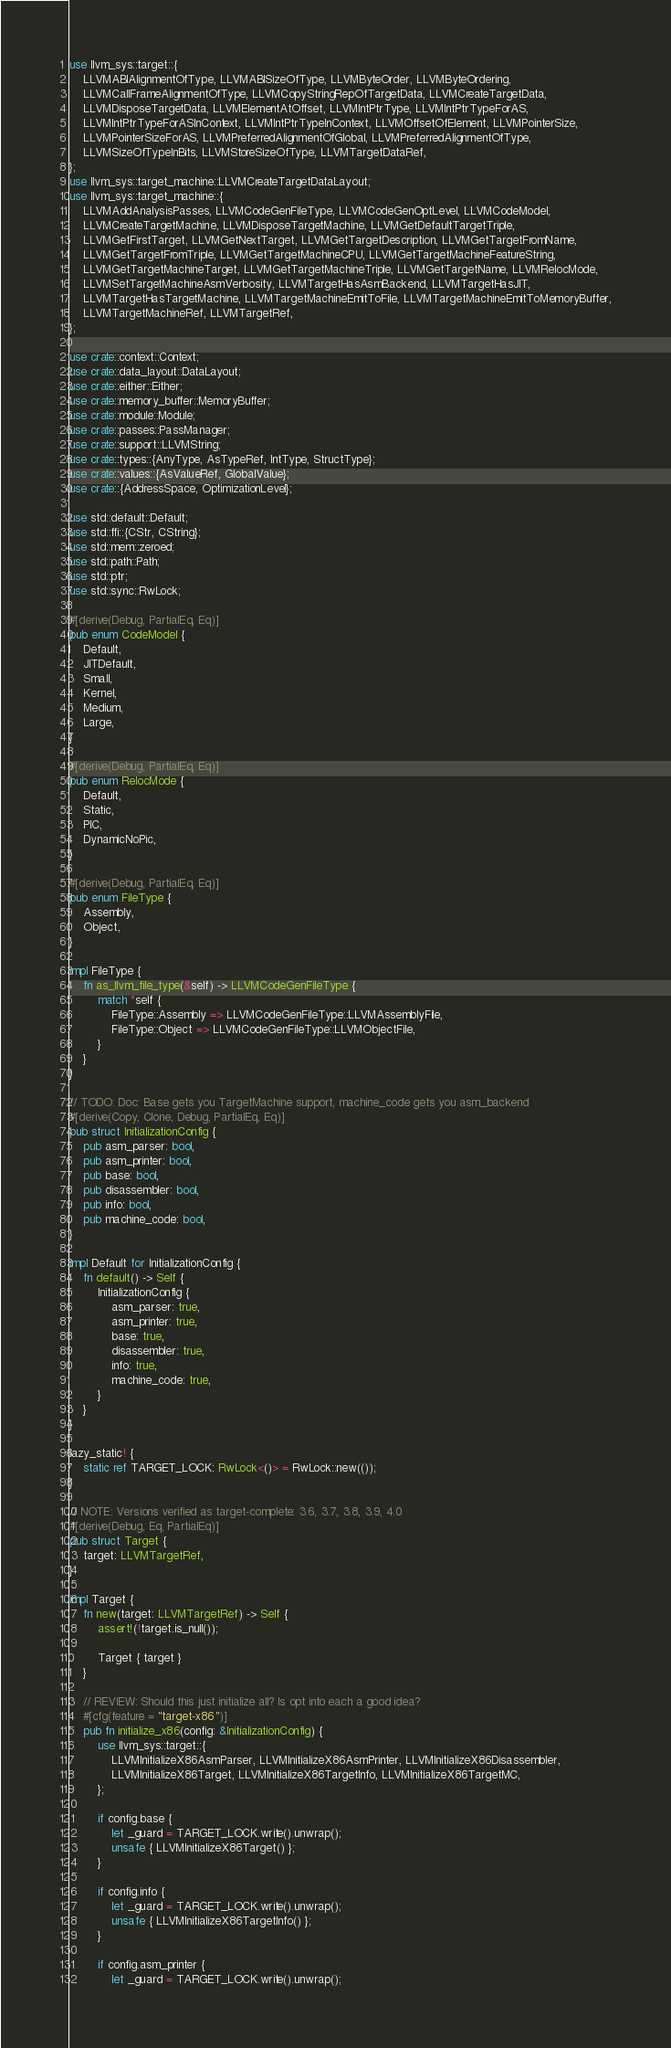Convert code to text. <code><loc_0><loc_0><loc_500><loc_500><_Rust_>use llvm_sys::target::{
    LLVMABIAlignmentOfType, LLVMABISizeOfType, LLVMByteOrder, LLVMByteOrdering,
    LLVMCallFrameAlignmentOfType, LLVMCopyStringRepOfTargetData, LLVMCreateTargetData,
    LLVMDisposeTargetData, LLVMElementAtOffset, LLVMIntPtrType, LLVMIntPtrTypeForAS,
    LLVMIntPtrTypeForASInContext, LLVMIntPtrTypeInContext, LLVMOffsetOfElement, LLVMPointerSize,
    LLVMPointerSizeForAS, LLVMPreferredAlignmentOfGlobal, LLVMPreferredAlignmentOfType,
    LLVMSizeOfTypeInBits, LLVMStoreSizeOfType, LLVMTargetDataRef,
};
use llvm_sys::target_machine::LLVMCreateTargetDataLayout;
use llvm_sys::target_machine::{
    LLVMAddAnalysisPasses, LLVMCodeGenFileType, LLVMCodeGenOptLevel, LLVMCodeModel,
    LLVMCreateTargetMachine, LLVMDisposeTargetMachine, LLVMGetDefaultTargetTriple,
    LLVMGetFirstTarget, LLVMGetNextTarget, LLVMGetTargetDescription, LLVMGetTargetFromName,
    LLVMGetTargetFromTriple, LLVMGetTargetMachineCPU, LLVMGetTargetMachineFeatureString,
    LLVMGetTargetMachineTarget, LLVMGetTargetMachineTriple, LLVMGetTargetName, LLVMRelocMode,
    LLVMSetTargetMachineAsmVerbosity, LLVMTargetHasAsmBackend, LLVMTargetHasJIT,
    LLVMTargetHasTargetMachine, LLVMTargetMachineEmitToFile, LLVMTargetMachineEmitToMemoryBuffer,
    LLVMTargetMachineRef, LLVMTargetRef,
};

use crate::context::Context;
use crate::data_layout::DataLayout;
use crate::either::Either;
use crate::memory_buffer::MemoryBuffer;
use crate::module::Module;
use crate::passes::PassManager;
use crate::support::LLVMString;
use crate::types::{AnyType, AsTypeRef, IntType, StructType};
use crate::values::{AsValueRef, GlobalValue};
use crate::{AddressSpace, OptimizationLevel};

use std::default::Default;
use std::ffi::{CStr, CString};
use std::mem::zeroed;
use std::path::Path;
use std::ptr;
use std::sync::RwLock;

#[derive(Debug, PartialEq, Eq)]
pub enum CodeModel {
    Default,
    JITDefault,
    Small,
    Kernel,
    Medium,
    Large,
}

#[derive(Debug, PartialEq, Eq)]
pub enum RelocMode {
    Default,
    Static,
    PIC,
    DynamicNoPic,
}

#[derive(Debug, PartialEq, Eq)]
pub enum FileType {
    Assembly,
    Object,
}

impl FileType {
    fn as_llvm_file_type(&self) -> LLVMCodeGenFileType {
        match *self {
            FileType::Assembly => LLVMCodeGenFileType::LLVMAssemblyFile,
            FileType::Object => LLVMCodeGenFileType::LLVMObjectFile,
        }
    }
}

// TODO: Doc: Base gets you TargetMachine support, machine_code gets you asm_backend
#[derive(Copy, Clone, Debug, PartialEq, Eq)]
pub struct InitializationConfig {
    pub asm_parser: bool,
    pub asm_printer: bool,
    pub base: bool,
    pub disassembler: bool,
    pub info: bool,
    pub machine_code: bool,
}

impl Default for InitializationConfig {
    fn default() -> Self {
        InitializationConfig {
            asm_parser: true,
            asm_printer: true,
            base: true,
            disassembler: true,
            info: true,
            machine_code: true,
        }
    }
}

lazy_static! {
    static ref TARGET_LOCK: RwLock<()> = RwLock::new(());
}

// NOTE: Versions verified as target-complete: 3.6, 3.7, 3.8, 3.9, 4.0
#[derive(Debug, Eq, PartialEq)]
pub struct Target {
    target: LLVMTargetRef,
}

impl Target {
    fn new(target: LLVMTargetRef) -> Self {
        assert!(!target.is_null());

        Target { target }
    }

    // REVIEW: Should this just initialize all? Is opt into each a good idea?
    #[cfg(feature = "target-x86")]
    pub fn initialize_x86(config: &InitializationConfig) {
        use llvm_sys::target::{
            LLVMInitializeX86AsmParser, LLVMInitializeX86AsmPrinter, LLVMInitializeX86Disassembler,
            LLVMInitializeX86Target, LLVMInitializeX86TargetInfo, LLVMInitializeX86TargetMC,
        };

        if config.base {
            let _guard = TARGET_LOCK.write().unwrap();
            unsafe { LLVMInitializeX86Target() };
        }

        if config.info {
            let _guard = TARGET_LOCK.write().unwrap();
            unsafe { LLVMInitializeX86TargetInfo() };
        }

        if config.asm_printer {
            let _guard = TARGET_LOCK.write().unwrap();</code> 